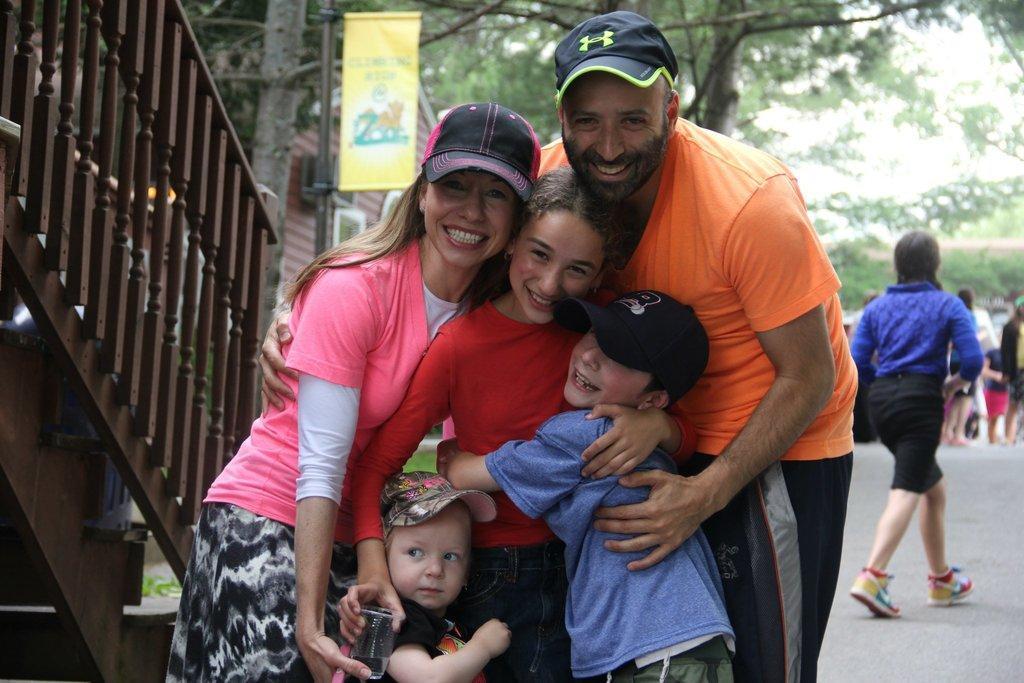In one or two sentences, can you explain what this image depicts? In this picture we can see there are groups of people standing and a person is walking on the road. On the left side of the people there are iron grilles and a pole with a board. Behind the people there are trees and it looks like a house. 